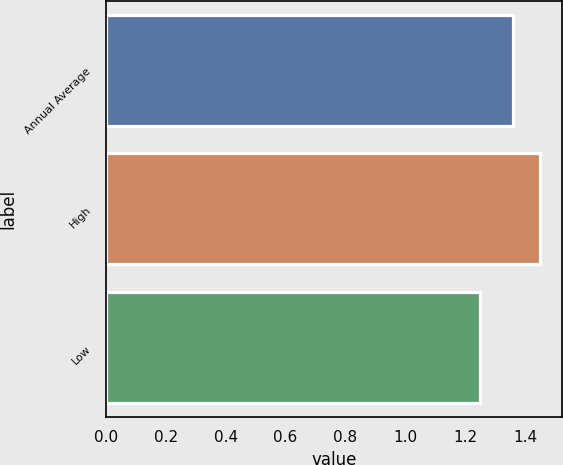Convert chart. <chart><loc_0><loc_0><loc_500><loc_500><bar_chart><fcel>Annual Average<fcel>High<fcel>Low<nl><fcel>1.36<fcel>1.45<fcel>1.25<nl></chart> 